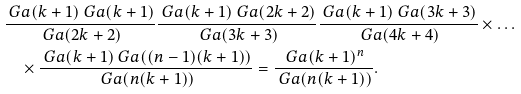Convert formula to latex. <formula><loc_0><loc_0><loc_500><loc_500>& \frac { \ G a ( k + 1 ) \ G a ( k + 1 ) } { \ G a ( 2 k + 2 ) } \frac { \ G a ( k + 1 ) \ G a ( 2 k + 2 ) } { \ G a ( 3 k + 3 ) } \frac { \ G a ( k + 1 ) \ G a ( 3 k + 3 ) } { \ G a ( 4 k + 4 ) } \times \dots \\ & \quad \times \frac { \ G a ( k + 1 ) \ G a ( ( n - 1 ) ( k + 1 ) ) } { \ G a ( n ( k + 1 ) ) } = \frac { \ G a ( k + 1 ) ^ { n } } { \ G a ( n ( k + 1 ) ) } .</formula> 